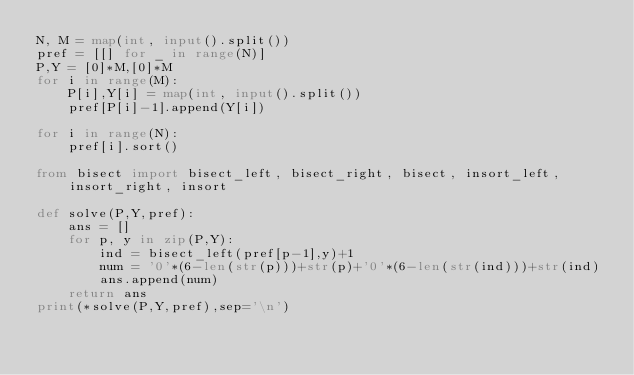Convert code to text. <code><loc_0><loc_0><loc_500><loc_500><_Python_>N, M = map(int, input().split())
pref = [[] for _ in range(N)]
P,Y = [0]*M,[0]*M
for i in range(M):
    P[i],Y[i] = map(int, input().split())
    pref[P[i]-1].append(Y[i])

for i in range(N):
    pref[i].sort()

from bisect import bisect_left, bisect_right, bisect, insort_left, insort_right, insort

def solve(P,Y,pref):
    ans = []
    for p, y in zip(P,Y):
        ind = bisect_left(pref[p-1],y)+1
        num = '0'*(6-len(str(p)))+str(p)+'0'*(6-len(str(ind)))+str(ind)
        ans.append(num)
    return ans
print(*solve(P,Y,pref),sep='\n')</code> 